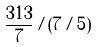Convert formula to latex. <formula><loc_0><loc_0><loc_500><loc_500>\frac { 3 1 3 } { 7 } / ( 7 / 5 )</formula> 